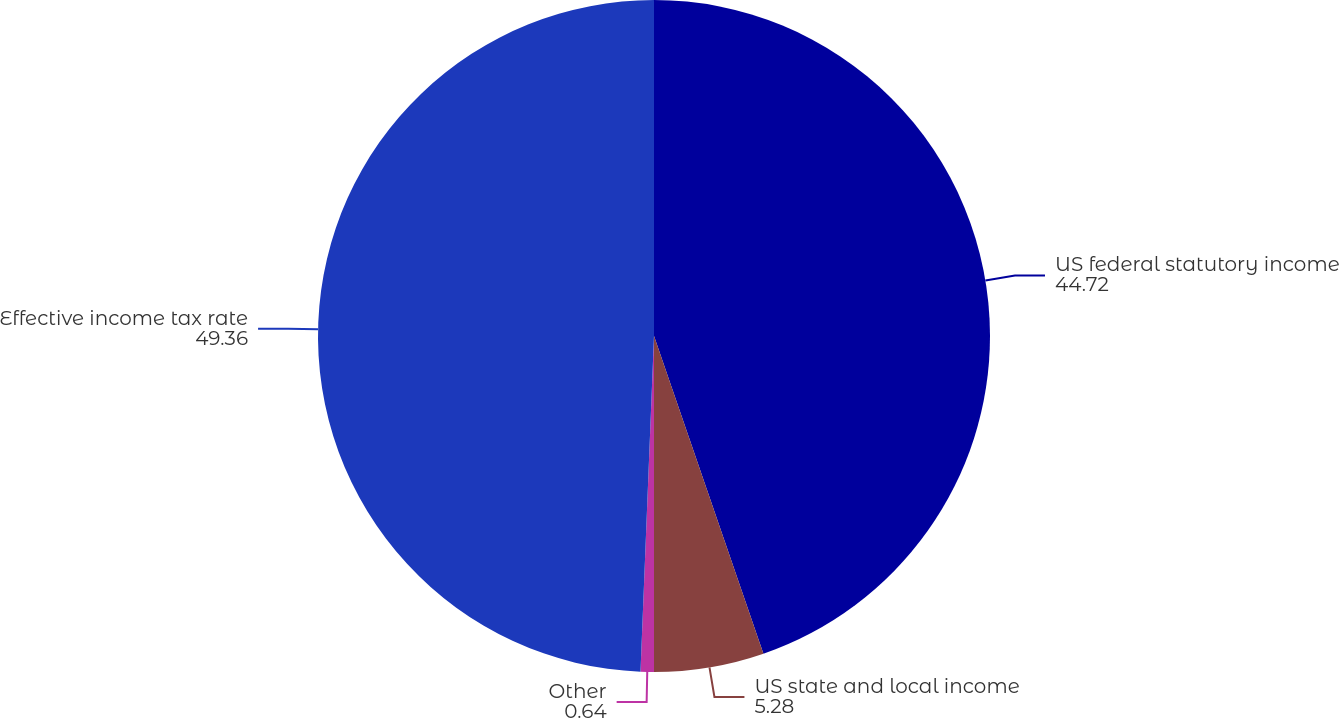Convert chart. <chart><loc_0><loc_0><loc_500><loc_500><pie_chart><fcel>US federal statutory income<fcel>US state and local income<fcel>Other<fcel>Effective income tax rate<nl><fcel>44.72%<fcel>5.28%<fcel>0.64%<fcel>49.36%<nl></chart> 